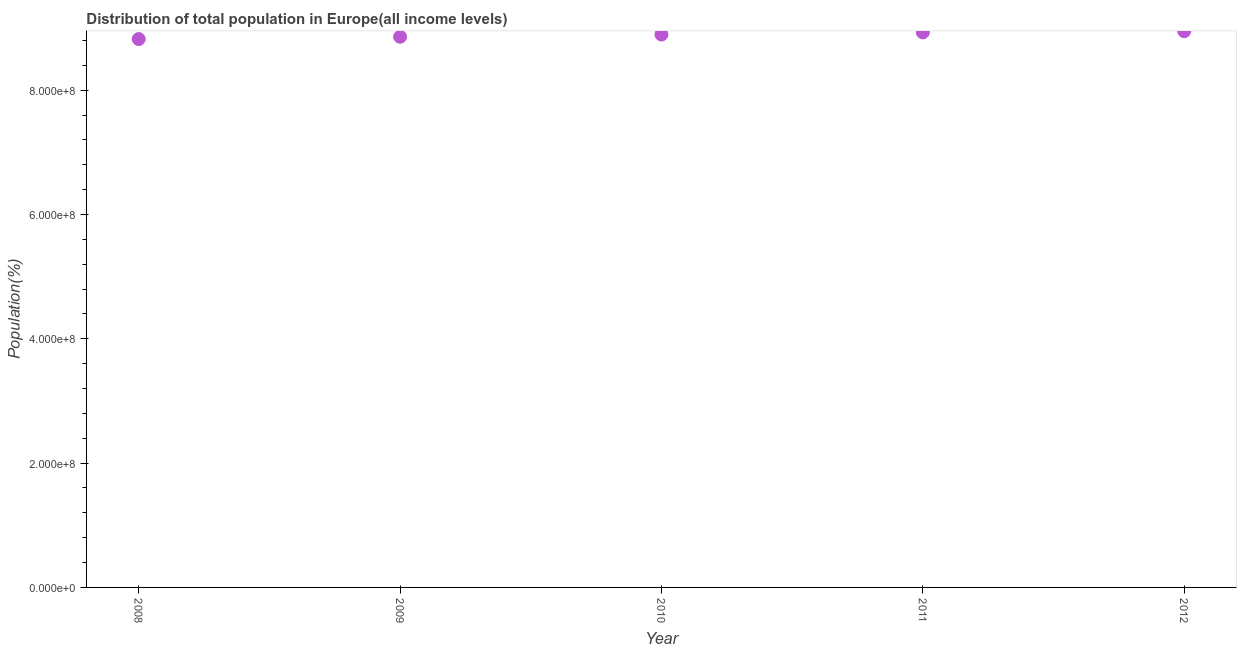What is the population in 2008?
Ensure brevity in your answer.  8.82e+08. Across all years, what is the maximum population?
Give a very brief answer. 8.95e+08. Across all years, what is the minimum population?
Give a very brief answer. 8.82e+08. In which year was the population minimum?
Give a very brief answer. 2008. What is the sum of the population?
Your answer should be compact. 4.45e+09. What is the difference between the population in 2009 and 2011?
Offer a terse response. -7.03e+06. What is the average population per year?
Ensure brevity in your answer.  8.89e+08. What is the median population?
Your response must be concise. 8.90e+08. In how many years, is the population greater than 560000000 %?
Keep it short and to the point. 5. Do a majority of the years between 2011 and 2008 (inclusive) have population greater than 600000000 %?
Give a very brief answer. Yes. What is the ratio of the population in 2008 to that in 2012?
Provide a succinct answer. 0.99. Is the difference between the population in 2008 and 2012 greater than the difference between any two years?
Make the answer very short. Yes. What is the difference between the highest and the second highest population?
Make the answer very short. 1.87e+06. What is the difference between the highest and the lowest population?
Provide a succinct answer. 1.26e+07. In how many years, is the population greater than the average population taken over all years?
Your answer should be very brief. 3. Are the values on the major ticks of Y-axis written in scientific E-notation?
Your answer should be very brief. Yes. Does the graph contain grids?
Provide a succinct answer. No. What is the title of the graph?
Provide a short and direct response. Distribution of total population in Europe(all income levels) . What is the label or title of the Y-axis?
Offer a terse response. Population(%). What is the Population(%) in 2008?
Your response must be concise. 8.82e+08. What is the Population(%) in 2009?
Your answer should be compact. 8.86e+08. What is the Population(%) in 2010?
Provide a short and direct response. 8.90e+08. What is the Population(%) in 2011?
Provide a short and direct response. 8.93e+08. What is the Population(%) in 2012?
Your answer should be very brief. 8.95e+08. What is the difference between the Population(%) in 2008 and 2009?
Ensure brevity in your answer.  -3.71e+06. What is the difference between the Population(%) in 2008 and 2010?
Give a very brief answer. -7.27e+06. What is the difference between the Population(%) in 2008 and 2011?
Make the answer very short. -1.07e+07. What is the difference between the Population(%) in 2008 and 2012?
Provide a succinct answer. -1.26e+07. What is the difference between the Population(%) in 2009 and 2010?
Offer a terse response. -3.57e+06. What is the difference between the Population(%) in 2009 and 2011?
Your answer should be compact. -7.03e+06. What is the difference between the Population(%) in 2009 and 2012?
Offer a terse response. -8.90e+06. What is the difference between the Population(%) in 2010 and 2011?
Your answer should be very brief. -3.46e+06. What is the difference between the Population(%) in 2010 and 2012?
Provide a short and direct response. -5.33e+06. What is the difference between the Population(%) in 2011 and 2012?
Your response must be concise. -1.87e+06. What is the ratio of the Population(%) in 2008 to that in 2009?
Offer a very short reply. 1. What is the ratio of the Population(%) in 2010 to that in 2011?
Provide a succinct answer. 1. What is the ratio of the Population(%) in 2010 to that in 2012?
Ensure brevity in your answer.  0.99. 